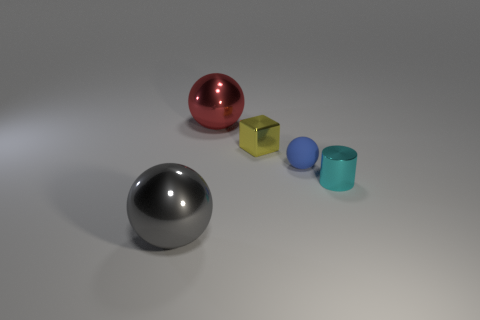Add 3 gray metal cubes. How many objects exist? 8 Subtract all red metallic spheres. How many spheres are left? 2 Subtract all cubes. How many objects are left? 4 Add 4 cylinders. How many cylinders are left? 5 Add 3 cyan shiny spheres. How many cyan shiny spheres exist? 3 Subtract all blue balls. How many balls are left? 2 Subtract 0 blue blocks. How many objects are left? 5 Subtract 1 cubes. How many cubes are left? 0 Subtract all yellow spheres. Subtract all cyan cylinders. How many spheres are left? 3 Subtract all brown matte blocks. Subtract all yellow metallic things. How many objects are left? 4 